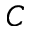Convert formula to latex. <formula><loc_0><loc_0><loc_500><loc_500>C</formula> 